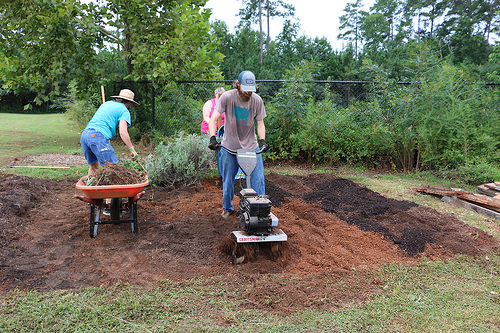<image>
Is the tiller behind the man? No. The tiller is not behind the man. From this viewpoint, the tiller appears to be positioned elsewhere in the scene. 